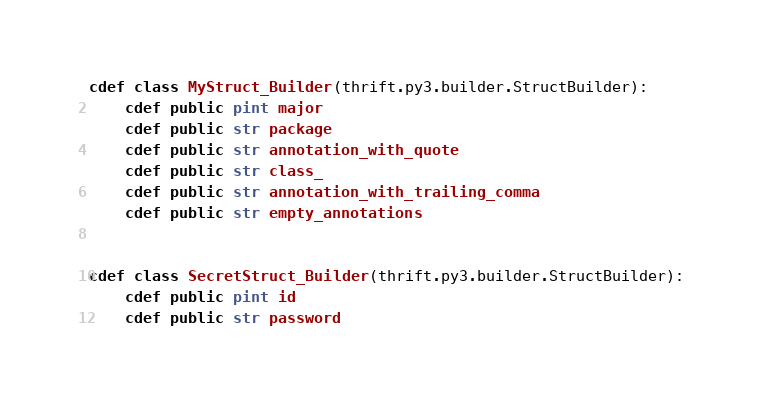<code> <loc_0><loc_0><loc_500><loc_500><_Cython_>
cdef class MyStruct_Builder(thrift.py3.builder.StructBuilder):
    cdef public pint major
    cdef public str package
    cdef public str annotation_with_quote
    cdef public str class_
    cdef public str annotation_with_trailing_comma
    cdef public str empty_annotations


cdef class SecretStruct_Builder(thrift.py3.builder.StructBuilder):
    cdef public pint id
    cdef public str password


</code> 